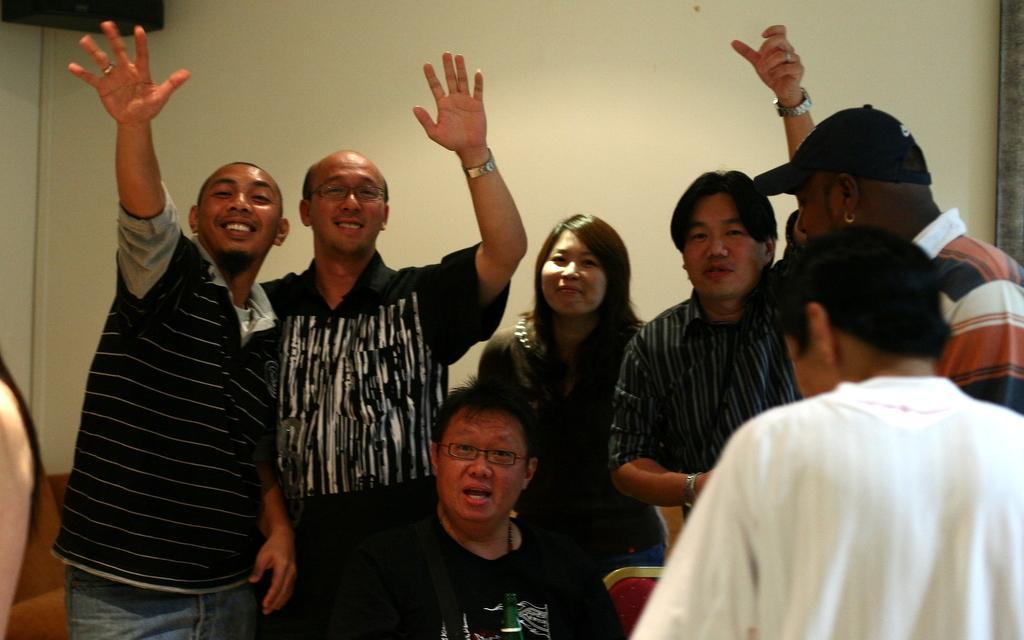How would you summarize this image in a sentence or two? In this picture I can see group of people standing, there is a person sitting, and in the background there is a wall and an object. 